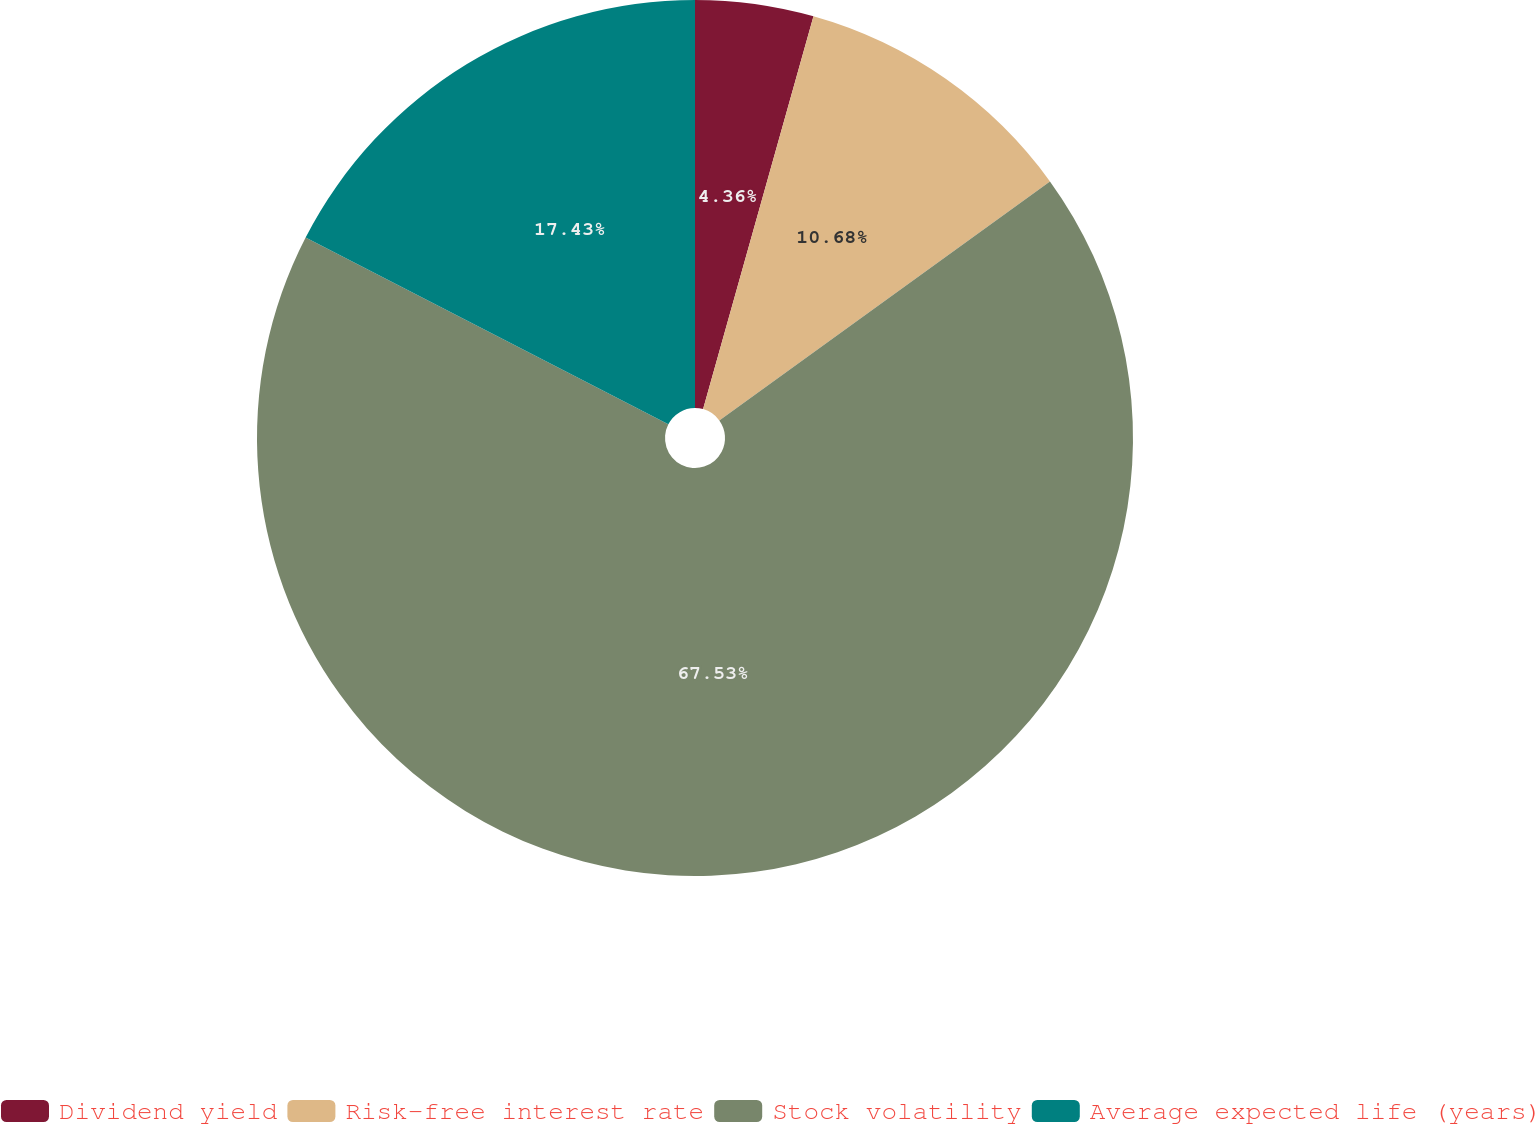Convert chart to OTSL. <chart><loc_0><loc_0><loc_500><loc_500><pie_chart><fcel>Dividend yield<fcel>Risk-free interest rate<fcel>Stock volatility<fcel>Average expected life (years)<nl><fcel>4.36%<fcel>10.68%<fcel>67.54%<fcel>17.43%<nl></chart> 